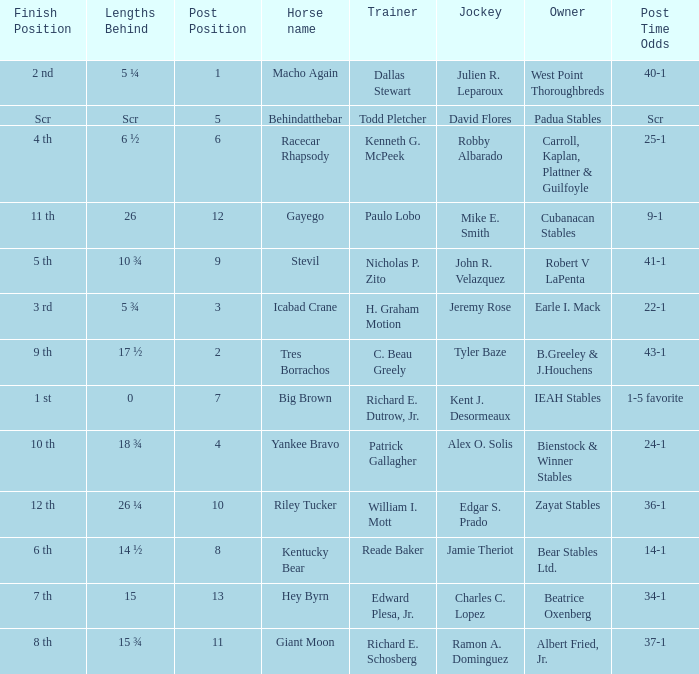Who is the owner of Icabad Crane? Earle I. Mack. 